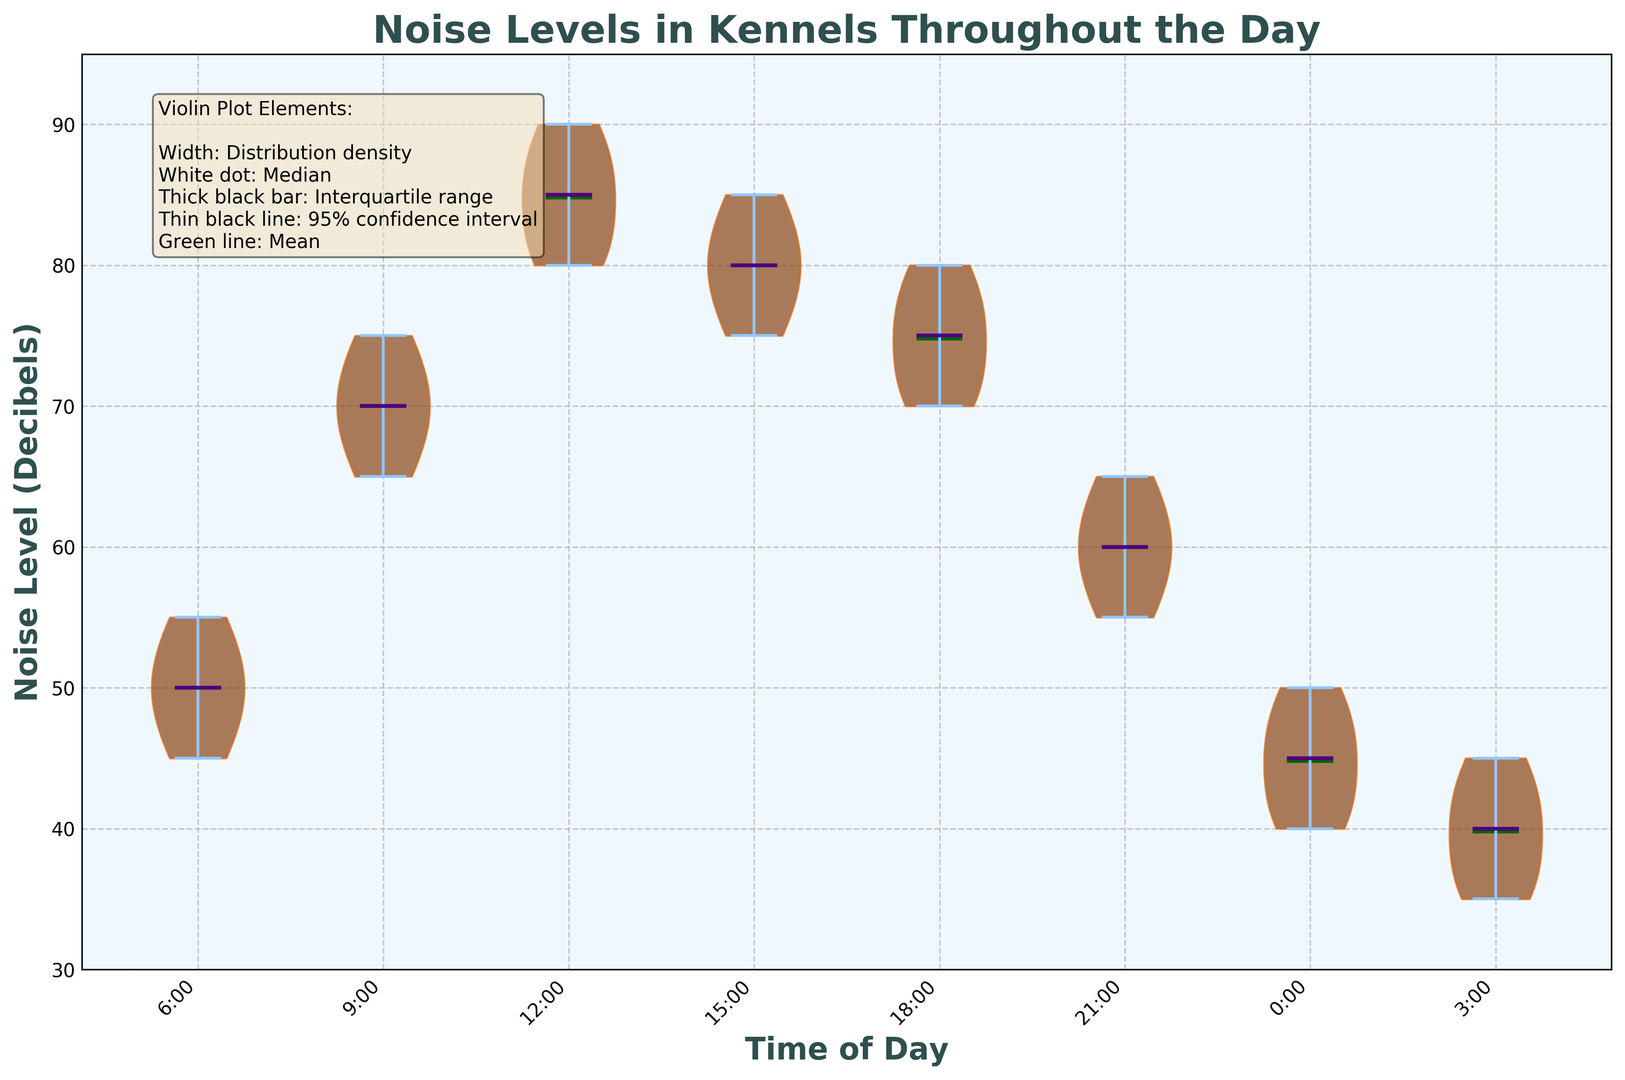What is the mean noise level at 6:00 AM? The figure shows that the green line represents the mean. At 6:00 AM, estimate the position of the green line on the vertical axis.
Answer: Approximately 50 dB Which time had the highest median noise level? The figure shows that the white dot in each violin plot represents the median. The highest white dot appears at 12:00 PM.
Answer: 12:00 PM How does the interquartile range of the noise levels at 3:00 AM compare to that at 12:00 PM? The thick black bar represents the interquartile range (IQR). Visual comparison shows the 3:00 AM IQR is narrower than the 12:00 PM IQR.
Answer: Narrower at 3:00 AM What time period shows the least variation in noise levels? Compare the widths of all violin plots. The time with the least variation will have the narrowest plot. The narrowest plot appears at 3:00 AM.
Answer: 3:00 AM What visual element indicates the 95% confidence interval for the means, and what does it show for 9:00 AM? The thin black line through the plot shows the 95% confidence interval. For 9:00 AM, it ranges approximately from 65 to 75 dB.
Answer: Thin black line; 65 to 75 dB Which time of day shows the most densely packed distribution in noise levels? The width of the violin plot indicates the density. The widest portion of a plot signifies the most densely packed values. The 9:00 AM plot appears to be the widest.
Answer: 9:00 AM Compare the maximum noise levels between 15:00 and 18:00. The extent of the plots at the top shows the maximum noise levels. For 15:00, the maximum reaches about 85 dB, and for 18:00, it reaches about 80 dB.
Answer: 15:00 is higher What does the color on the violin plot body represent, and what color is used? The color of the violin plot body represents the distribution density with brownish shades used.
Answer: Brown How does the noise level distribution at midnight (0:00) compare visually to other times of the day? The midnight plot is narrower with lower decibels, indicating less variation and lower noise levels overall compared to other times.
Answer: Less variation, lower levels 